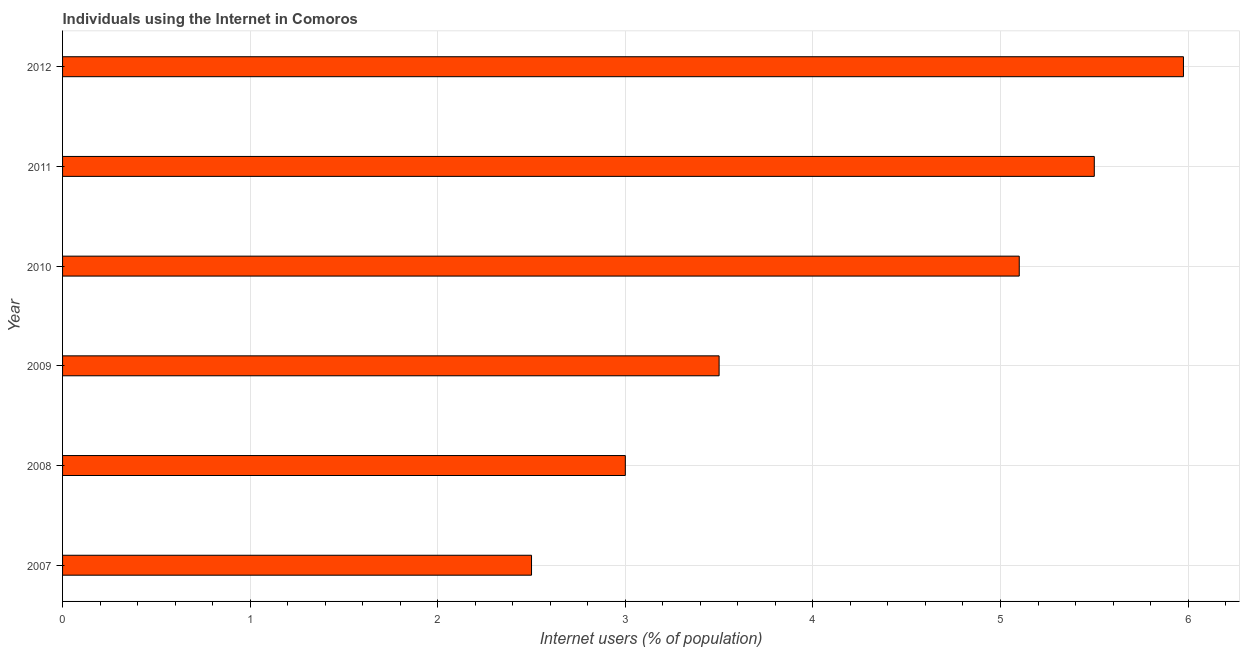What is the title of the graph?
Keep it short and to the point. Individuals using the Internet in Comoros. What is the label or title of the X-axis?
Your response must be concise. Internet users (% of population). What is the label or title of the Y-axis?
Keep it short and to the point. Year. What is the number of internet users in 2012?
Your answer should be very brief. 5.98. Across all years, what is the maximum number of internet users?
Provide a short and direct response. 5.98. Across all years, what is the minimum number of internet users?
Provide a succinct answer. 2.5. In which year was the number of internet users maximum?
Offer a very short reply. 2012. What is the sum of the number of internet users?
Provide a succinct answer. 25.58. What is the difference between the number of internet users in 2007 and 2009?
Offer a terse response. -1. What is the average number of internet users per year?
Keep it short and to the point. 4.26. In how many years, is the number of internet users greater than 1.2 %?
Your response must be concise. 6. What is the ratio of the number of internet users in 2008 to that in 2012?
Your response must be concise. 0.5. Is the difference between the number of internet users in 2008 and 2011 greater than the difference between any two years?
Ensure brevity in your answer.  No. What is the difference between the highest and the second highest number of internet users?
Your answer should be very brief. 0.47. What is the difference between the highest and the lowest number of internet users?
Provide a succinct answer. 3.48. How many bars are there?
Ensure brevity in your answer.  6. What is the difference between two consecutive major ticks on the X-axis?
Your response must be concise. 1. What is the Internet users (% of population) in 2007?
Provide a short and direct response. 2.5. What is the Internet users (% of population) of 2010?
Provide a succinct answer. 5.1. What is the Internet users (% of population) of 2011?
Make the answer very short. 5.5. What is the Internet users (% of population) of 2012?
Provide a short and direct response. 5.98. What is the difference between the Internet users (% of population) in 2007 and 2008?
Provide a succinct answer. -0.5. What is the difference between the Internet users (% of population) in 2007 and 2009?
Your answer should be very brief. -1. What is the difference between the Internet users (% of population) in 2007 and 2012?
Your answer should be compact. -3.48. What is the difference between the Internet users (% of population) in 2008 and 2011?
Provide a short and direct response. -2.5. What is the difference between the Internet users (% of population) in 2008 and 2012?
Ensure brevity in your answer.  -2.98. What is the difference between the Internet users (% of population) in 2009 and 2012?
Provide a short and direct response. -2.48. What is the difference between the Internet users (% of population) in 2010 and 2012?
Provide a succinct answer. -0.88. What is the difference between the Internet users (% of population) in 2011 and 2012?
Your answer should be compact. -0.48. What is the ratio of the Internet users (% of population) in 2007 to that in 2008?
Your answer should be compact. 0.83. What is the ratio of the Internet users (% of population) in 2007 to that in 2009?
Your response must be concise. 0.71. What is the ratio of the Internet users (% of population) in 2007 to that in 2010?
Offer a very short reply. 0.49. What is the ratio of the Internet users (% of population) in 2007 to that in 2011?
Your answer should be compact. 0.46. What is the ratio of the Internet users (% of population) in 2007 to that in 2012?
Make the answer very short. 0.42. What is the ratio of the Internet users (% of population) in 2008 to that in 2009?
Your response must be concise. 0.86. What is the ratio of the Internet users (% of population) in 2008 to that in 2010?
Provide a short and direct response. 0.59. What is the ratio of the Internet users (% of population) in 2008 to that in 2011?
Your response must be concise. 0.55. What is the ratio of the Internet users (% of population) in 2008 to that in 2012?
Offer a terse response. 0.5. What is the ratio of the Internet users (% of population) in 2009 to that in 2010?
Offer a very short reply. 0.69. What is the ratio of the Internet users (% of population) in 2009 to that in 2011?
Offer a terse response. 0.64. What is the ratio of the Internet users (% of population) in 2009 to that in 2012?
Your response must be concise. 0.59. What is the ratio of the Internet users (% of population) in 2010 to that in 2011?
Your response must be concise. 0.93. What is the ratio of the Internet users (% of population) in 2010 to that in 2012?
Provide a short and direct response. 0.85. What is the ratio of the Internet users (% of population) in 2011 to that in 2012?
Ensure brevity in your answer.  0.92. 